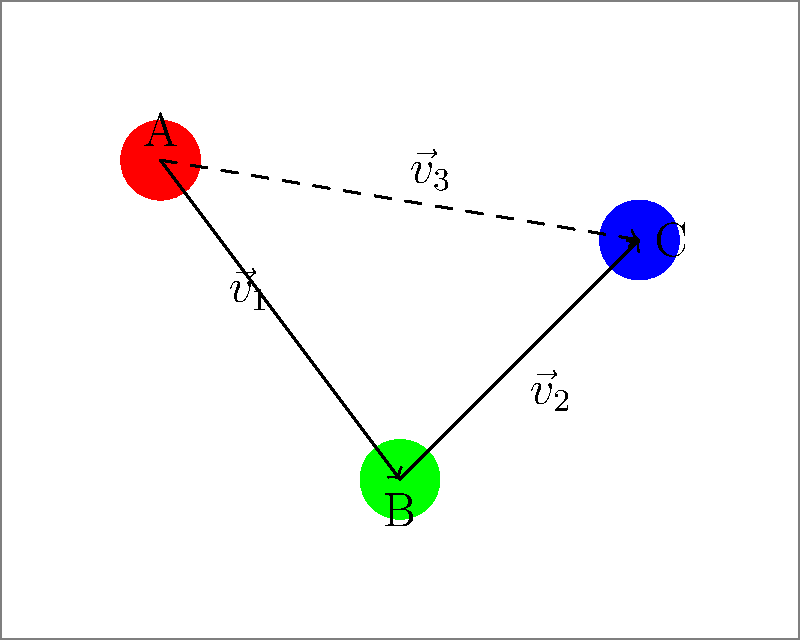Given a circuit board with three components A, B, and C positioned as shown in the diagram, determine the vector $\vec{v}_3$ that represents the optimal path from component A to component C. Express your answer in terms of $\vec{v}_1$ and $\vec{v}_2$. To solve this problem, we need to use vector addition:

1. Observe that $\vec{v}_3$ is the vector from A to C.
2. We can reach C from A by first going from A to B (vector $\vec{v}_1$), and then from B to C (vector $\vec{v}_2$).
3. This means that $\vec{v}_3$ is the sum of $\vec{v}_1$ and $\vec{v}_2$.
4. In vector notation, this can be expressed as:

   $$\vec{v}_3 = \vec{v}_1 + \vec{v}_2$$

5. This equation represents the optimal path from A to C using the existing connections on the circuit board.
6. The result is a single vector $\vec{v}_3$ that directly connects A to C, which is the most efficient route for signal transmission or component interaction.
Answer: $\vec{v}_3 = \vec{v}_1 + \vec{v}_2$ 